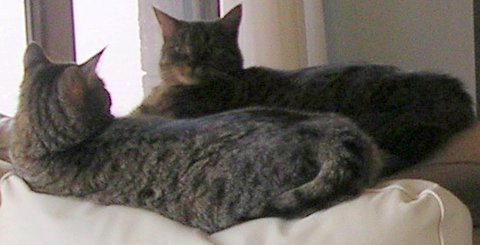Describe the objects in this image and their specific colors. I can see cat in white, gray, and black tones, cat in white, black, and gray tones, and couch in white, darkgray, lightgray, and gray tones in this image. 